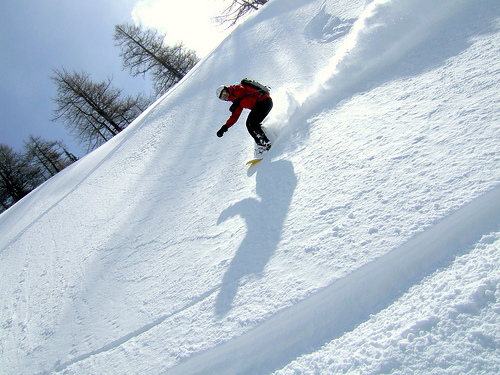<image>
Is the person to the right of the tree? Yes. From this viewpoint, the person is positioned to the right side relative to the tree. Where is the dog in relation to the grass? Is it next to the grass? Yes. The dog is positioned adjacent to the grass, located nearby in the same general area. 